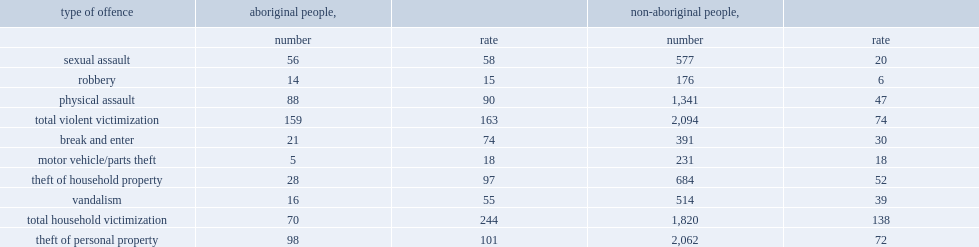In 2014, which kind of people had the higher overall rate of violence, among aboriginal people or non-aboriginal people? Aboriginal people,. Which kind of people had the higher overall rate of household victimization, aboriginal households or non-aboriginal households? Aboriginal people,. 